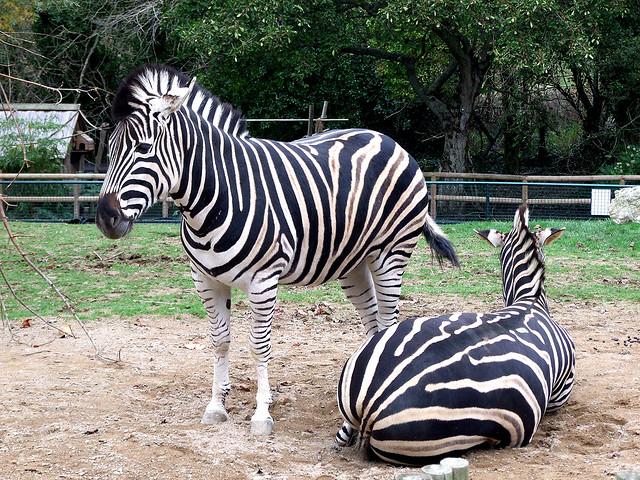Are these animals facing the same direction?
Write a very short answer. No. How many zebras are in this photo?
Be succinct. 2. Are the zebra's in a pen?
Be succinct. Yes. 